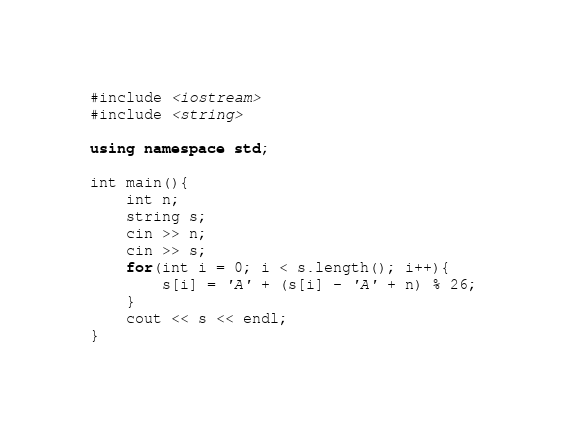Convert code to text. <code><loc_0><loc_0><loc_500><loc_500><_C++_>#include <iostream>
#include <string>

using namespace std;

int main(){
    int n;
    string s;
    cin >> n;
    cin >> s;
    for(int i = 0; i < s.length(); i++){
        s[i] = 'A' + (s[i] - 'A' + n) % 26;
    }
    cout << s << endl;
}</code> 